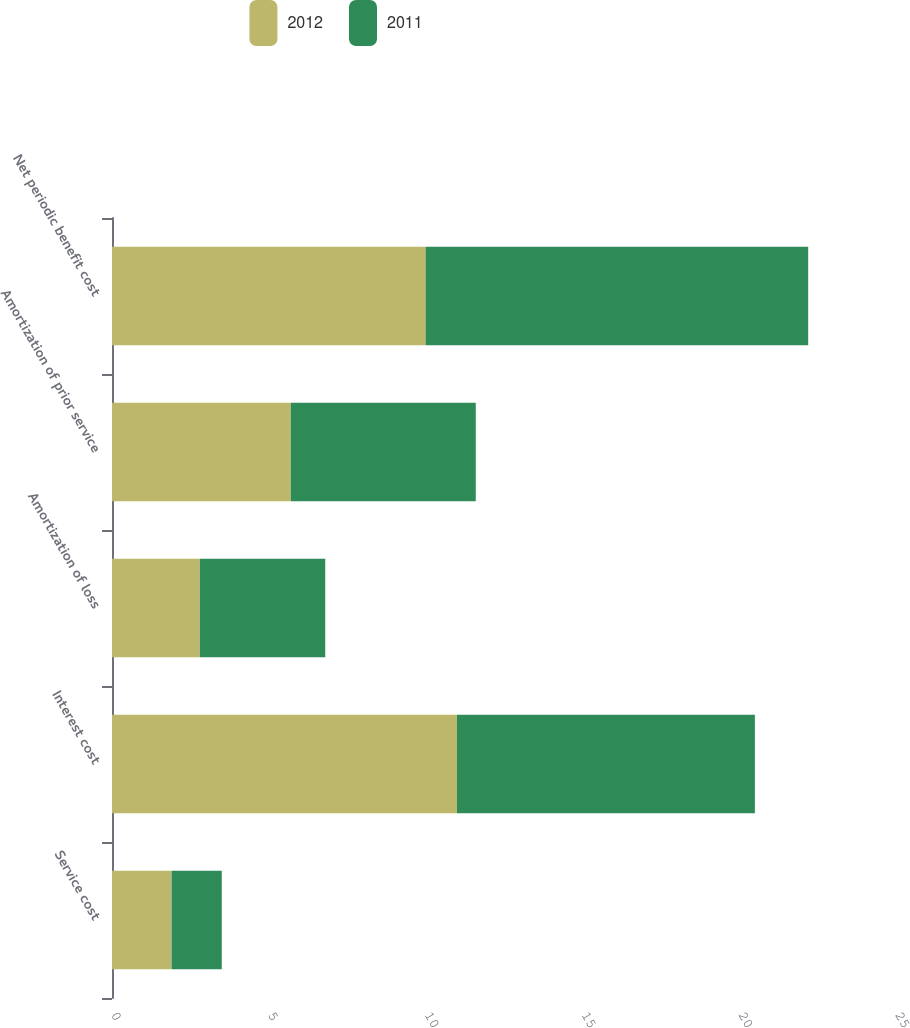<chart> <loc_0><loc_0><loc_500><loc_500><stacked_bar_chart><ecel><fcel>Service cost<fcel>Interest cost<fcel>Amortization of loss<fcel>Amortization of prior service<fcel>Net periodic benefit cost<nl><fcel>2012<fcel>1.9<fcel>11<fcel>2.8<fcel>5.7<fcel>10<nl><fcel>2011<fcel>1.6<fcel>9.5<fcel>4<fcel>5.9<fcel>12.2<nl></chart> 